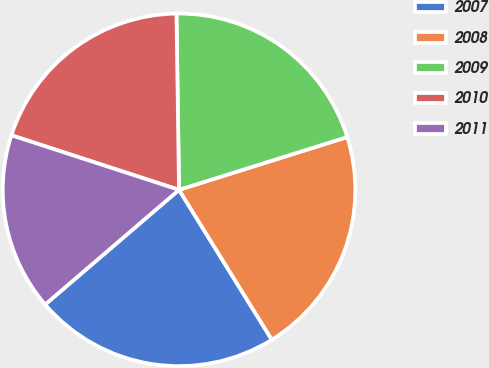<chart> <loc_0><loc_0><loc_500><loc_500><pie_chart><fcel>2007<fcel>2008<fcel>2009<fcel>2010<fcel>2011<nl><fcel>22.55%<fcel>21.02%<fcel>20.39%<fcel>19.76%<fcel>16.28%<nl></chart> 